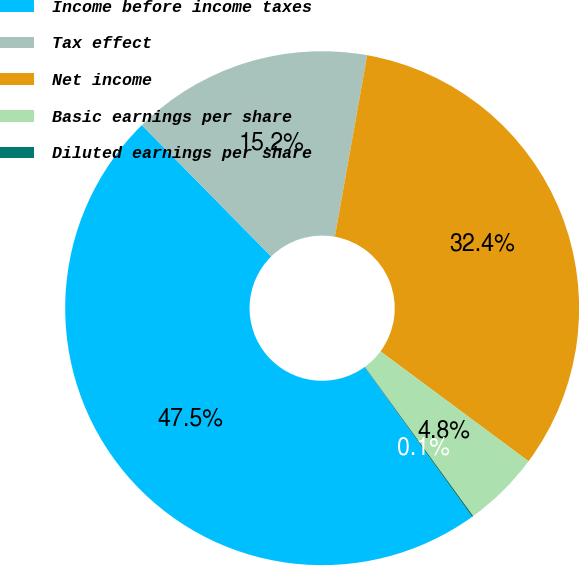Convert chart. <chart><loc_0><loc_0><loc_500><loc_500><pie_chart><fcel>Income before income taxes<fcel>Tax effect<fcel>Net income<fcel>Basic earnings per share<fcel>Diluted earnings per share<nl><fcel>47.53%<fcel>15.18%<fcel>32.35%<fcel>4.84%<fcel>0.09%<nl></chart> 